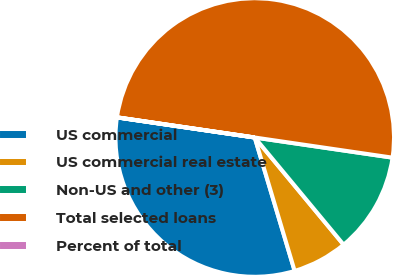Convert chart to OTSL. <chart><loc_0><loc_0><loc_500><loc_500><pie_chart><fcel>US commercial<fcel>US commercial real estate<fcel>Non-US and other (3)<fcel>Total selected loans<fcel>Percent of total<nl><fcel>31.93%<fcel>6.39%<fcel>11.67%<fcel>49.99%<fcel>0.01%<nl></chart> 